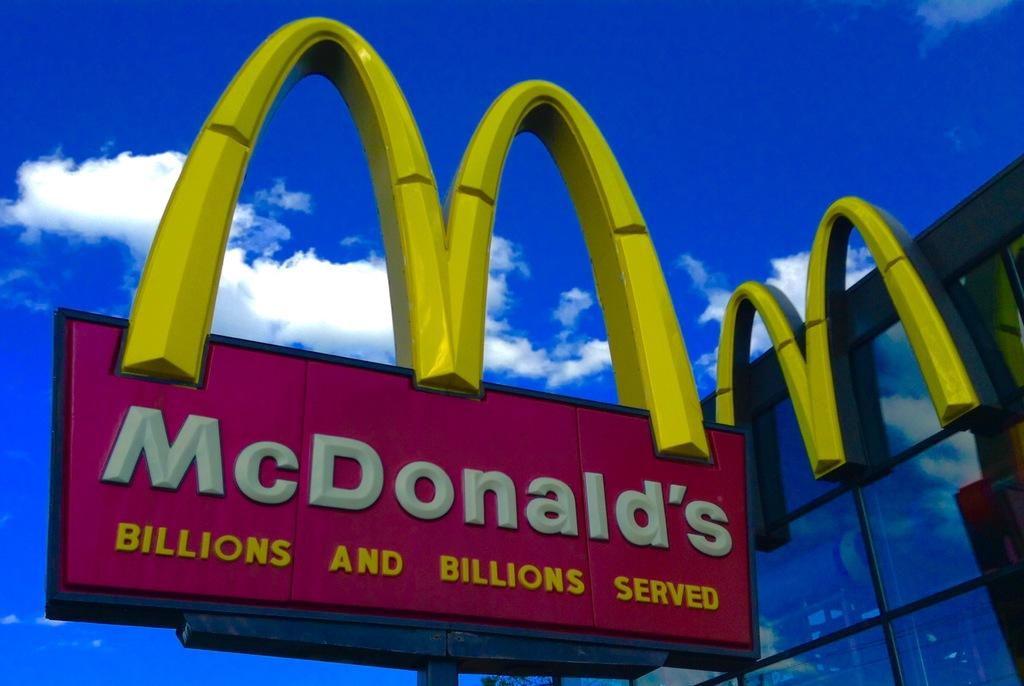<image>
Share a concise interpretation of the image provided. McDonald's sign in front of a blue and cloudy sky. 